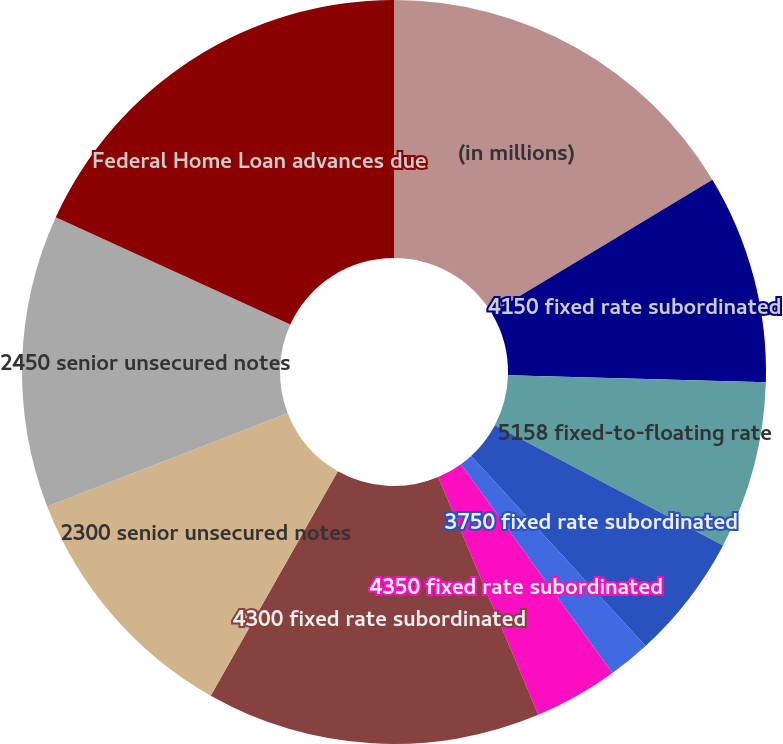Convert chart to OTSL. <chart><loc_0><loc_0><loc_500><loc_500><pie_chart><fcel>(in millions)<fcel>4150 fixed rate subordinated<fcel>5158 fixed-to-floating rate<fcel>3750 fixed rate subordinated<fcel>4023 fixed rate subordinated<fcel>4350 fixed rate subordinated<fcel>4300 fixed rate subordinated<fcel>2300 senior unsecured notes<fcel>2450 senior unsecured notes<fcel>Federal Home Loan advances due<nl><fcel>16.35%<fcel>9.09%<fcel>7.28%<fcel>5.46%<fcel>1.83%<fcel>3.65%<fcel>14.54%<fcel>10.91%<fcel>12.72%<fcel>18.17%<nl></chart> 